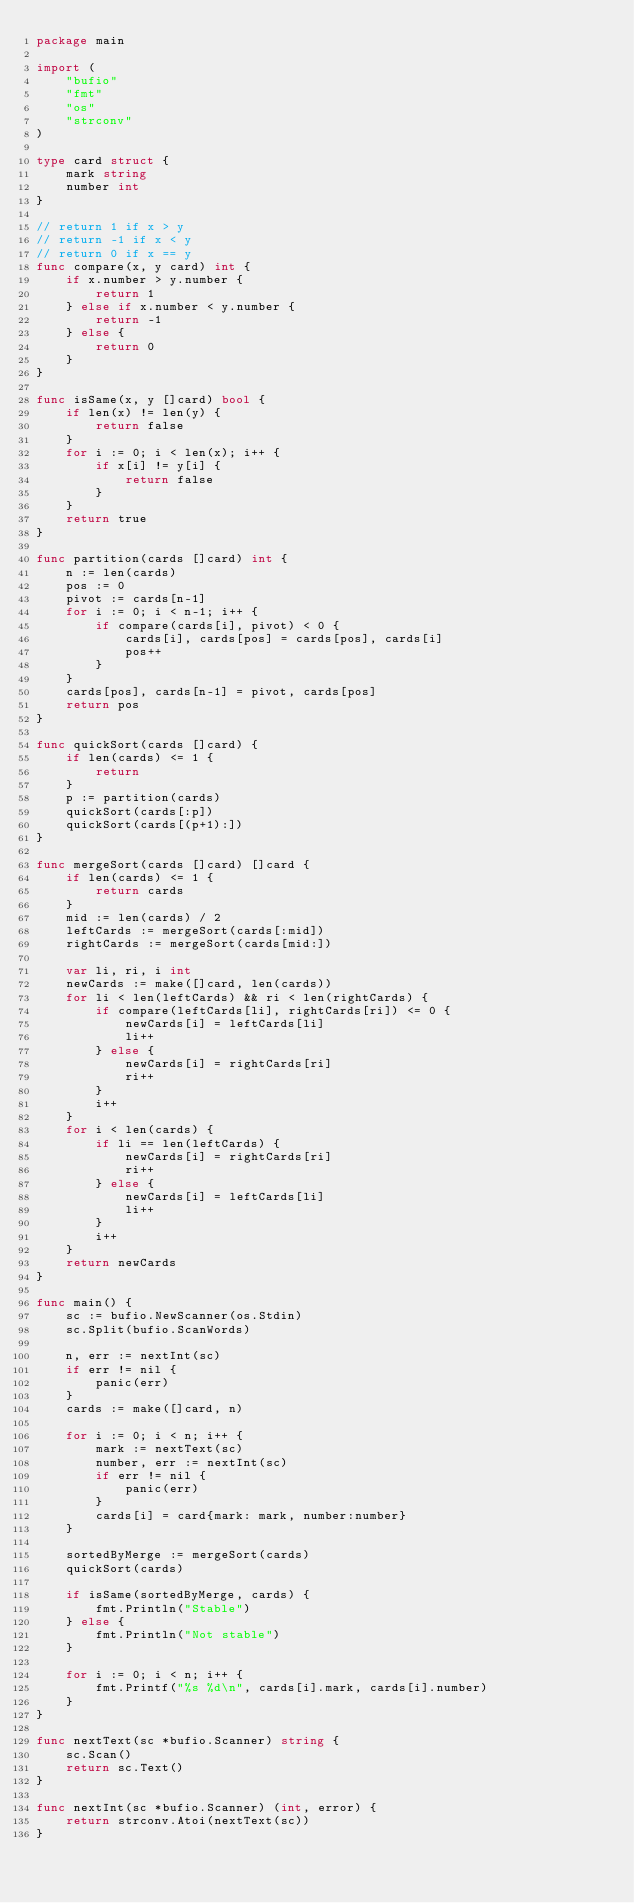Convert code to text. <code><loc_0><loc_0><loc_500><loc_500><_Go_>package main

import (
	"bufio"
	"fmt"
	"os"
	"strconv"
)

type card struct {
	mark string
	number int
}

// return 1 if x > y
// return -1 if x < y
// return 0 if x == y
func compare(x, y card) int {
	if x.number > y.number {
		return 1
	} else if x.number < y.number {
		return -1
	} else {
		return 0
	}
}

func isSame(x, y []card) bool {
	if len(x) != len(y) {
		return false
	}
	for i := 0; i < len(x); i++ {
		if x[i] != y[i] {
			return false
		}
	}
	return true
}

func partition(cards []card) int {
	n := len(cards)
	pos := 0
	pivot := cards[n-1]
	for i := 0; i < n-1; i++ {
		if compare(cards[i], pivot) < 0 {
			cards[i], cards[pos] = cards[pos], cards[i]
			pos++
		}
	}
	cards[pos], cards[n-1] = pivot, cards[pos]
	return pos
}

func quickSort(cards []card) {
	if len(cards) <= 1 {
		return
	}
	p := partition(cards)
	quickSort(cards[:p])
	quickSort(cards[(p+1):])
}

func mergeSort(cards []card) []card {
	if len(cards) <= 1 {
		return cards
	}
	mid := len(cards) / 2
	leftCards := mergeSort(cards[:mid])
	rightCards := mergeSort(cards[mid:])

	var li, ri, i int
	newCards := make([]card, len(cards))
	for li < len(leftCards) && ri < len(rightCards) {
		if compare(leftCards[li], rightCards[ri]) <= 0 {
			newCards[i] = leftCards[li]
			li++
		} else {
			newCards[i] = rightCards[ri]
			ri++
		}
		i++
	}
	for i < len(cards) {
		if li == len(leftCards) {
			newCards[i] = rightCards[ri]
			ri++
		} else {
			newCards[i] = leftCards[li]
			li++
		}
		i++
	}
	return newCards
}

func main() {
	sc := bufio.NewScanner(os.Stdin)
	sc.Split(bufio.ScanWords)

	n, err := nextInt(sc)
	if err != nil {
		panic(err)
	}
	cards := make([]card, n)

	for i := 0; i < n; i++ {
		mark := nextText(sc)
		number, err := nextInt(sc)
		if err != nil {
			panic(err)
		}
		cards[i] = card{mark: mark, number:number}
	}

	sortedByMerge := mergeSort(cards)
	quickSort(cards)

	if isSame(sortedByMerge, cards) {
		fmt.Println("Stable")
	} else {
		fmt.Println("Not stable")
	}

	for i := 0; i < n; i++ {
		fmt.Printf("%s %d\n", cards[i].mark, cards[i].number)
	}
}

func nextText(sc *bufio.Scanner) string {
	sc.Scan()
	return sc.Text()
}

func nextInt(sc *bufio.Scanner) (int, error) {
	return strconv.Atoi(nextText(sc))
}
</code> 